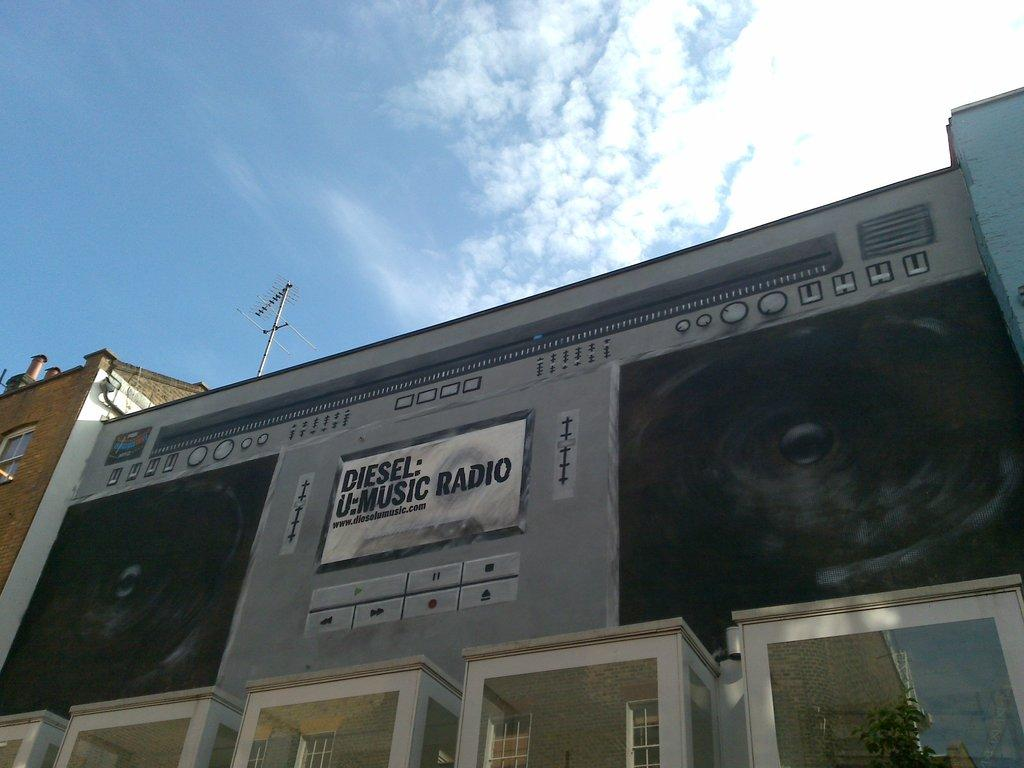What type of structures are present in the image? There are buildings in the image. What is placed on the buildings? Boards are placed on the buildings. What can be seen in the background of the image? The sky is visible in the background of the image. What type of cup is being used to collect rainwater from the pocket in the image? There is no cup or pocket present in the image, and therefore no such activity can be observed. 